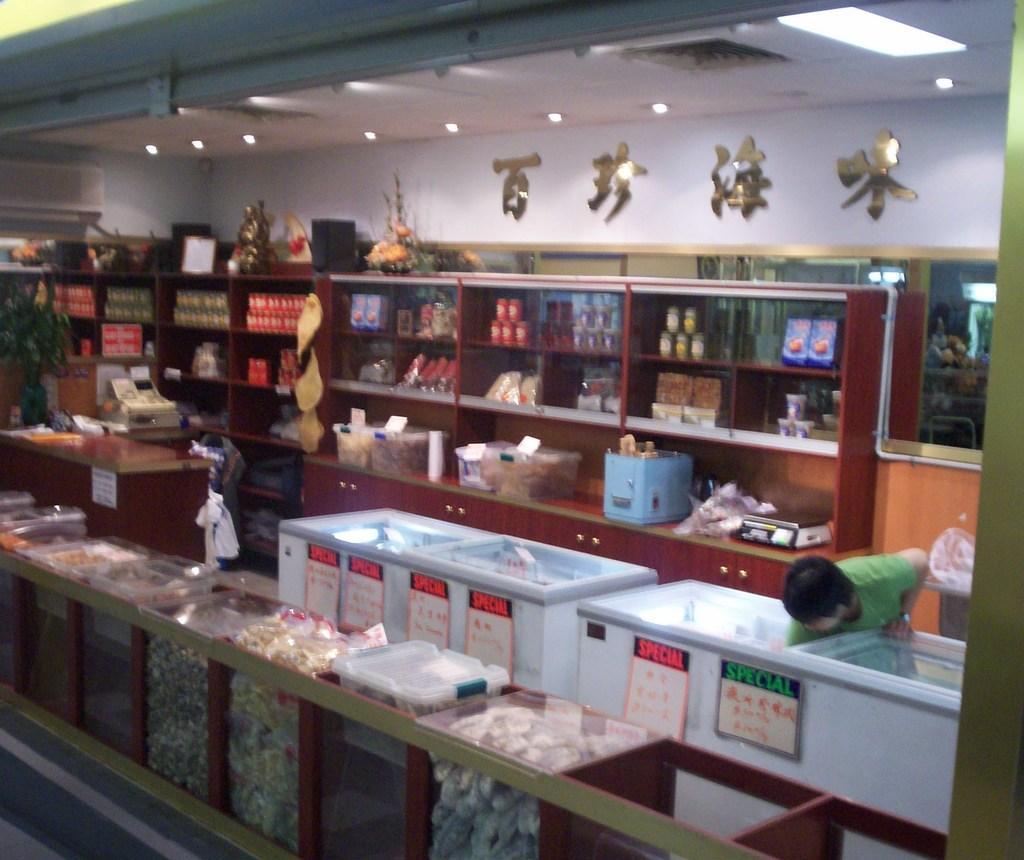Describe this image in one or two sentences. This picture is clicked inside the room. In the foreground we can see the cabinets containing many numbers of objects. On the right there is a person standing and bending forward and we can see the white color objects which seems to be the refrigerators and we can see the text on the posters. At the top there is a roof and the ceiling lights. In the background we can see the wall and some objects hanging on the wall and we can see the sculpture of some object and we can see the green leaves, machines and the wooden cabinets containing boxes and many other products and we can see some other objects in the background. In the foreground we can see an object which seems to be the sculpture which is placed on the top of the cabinet. 